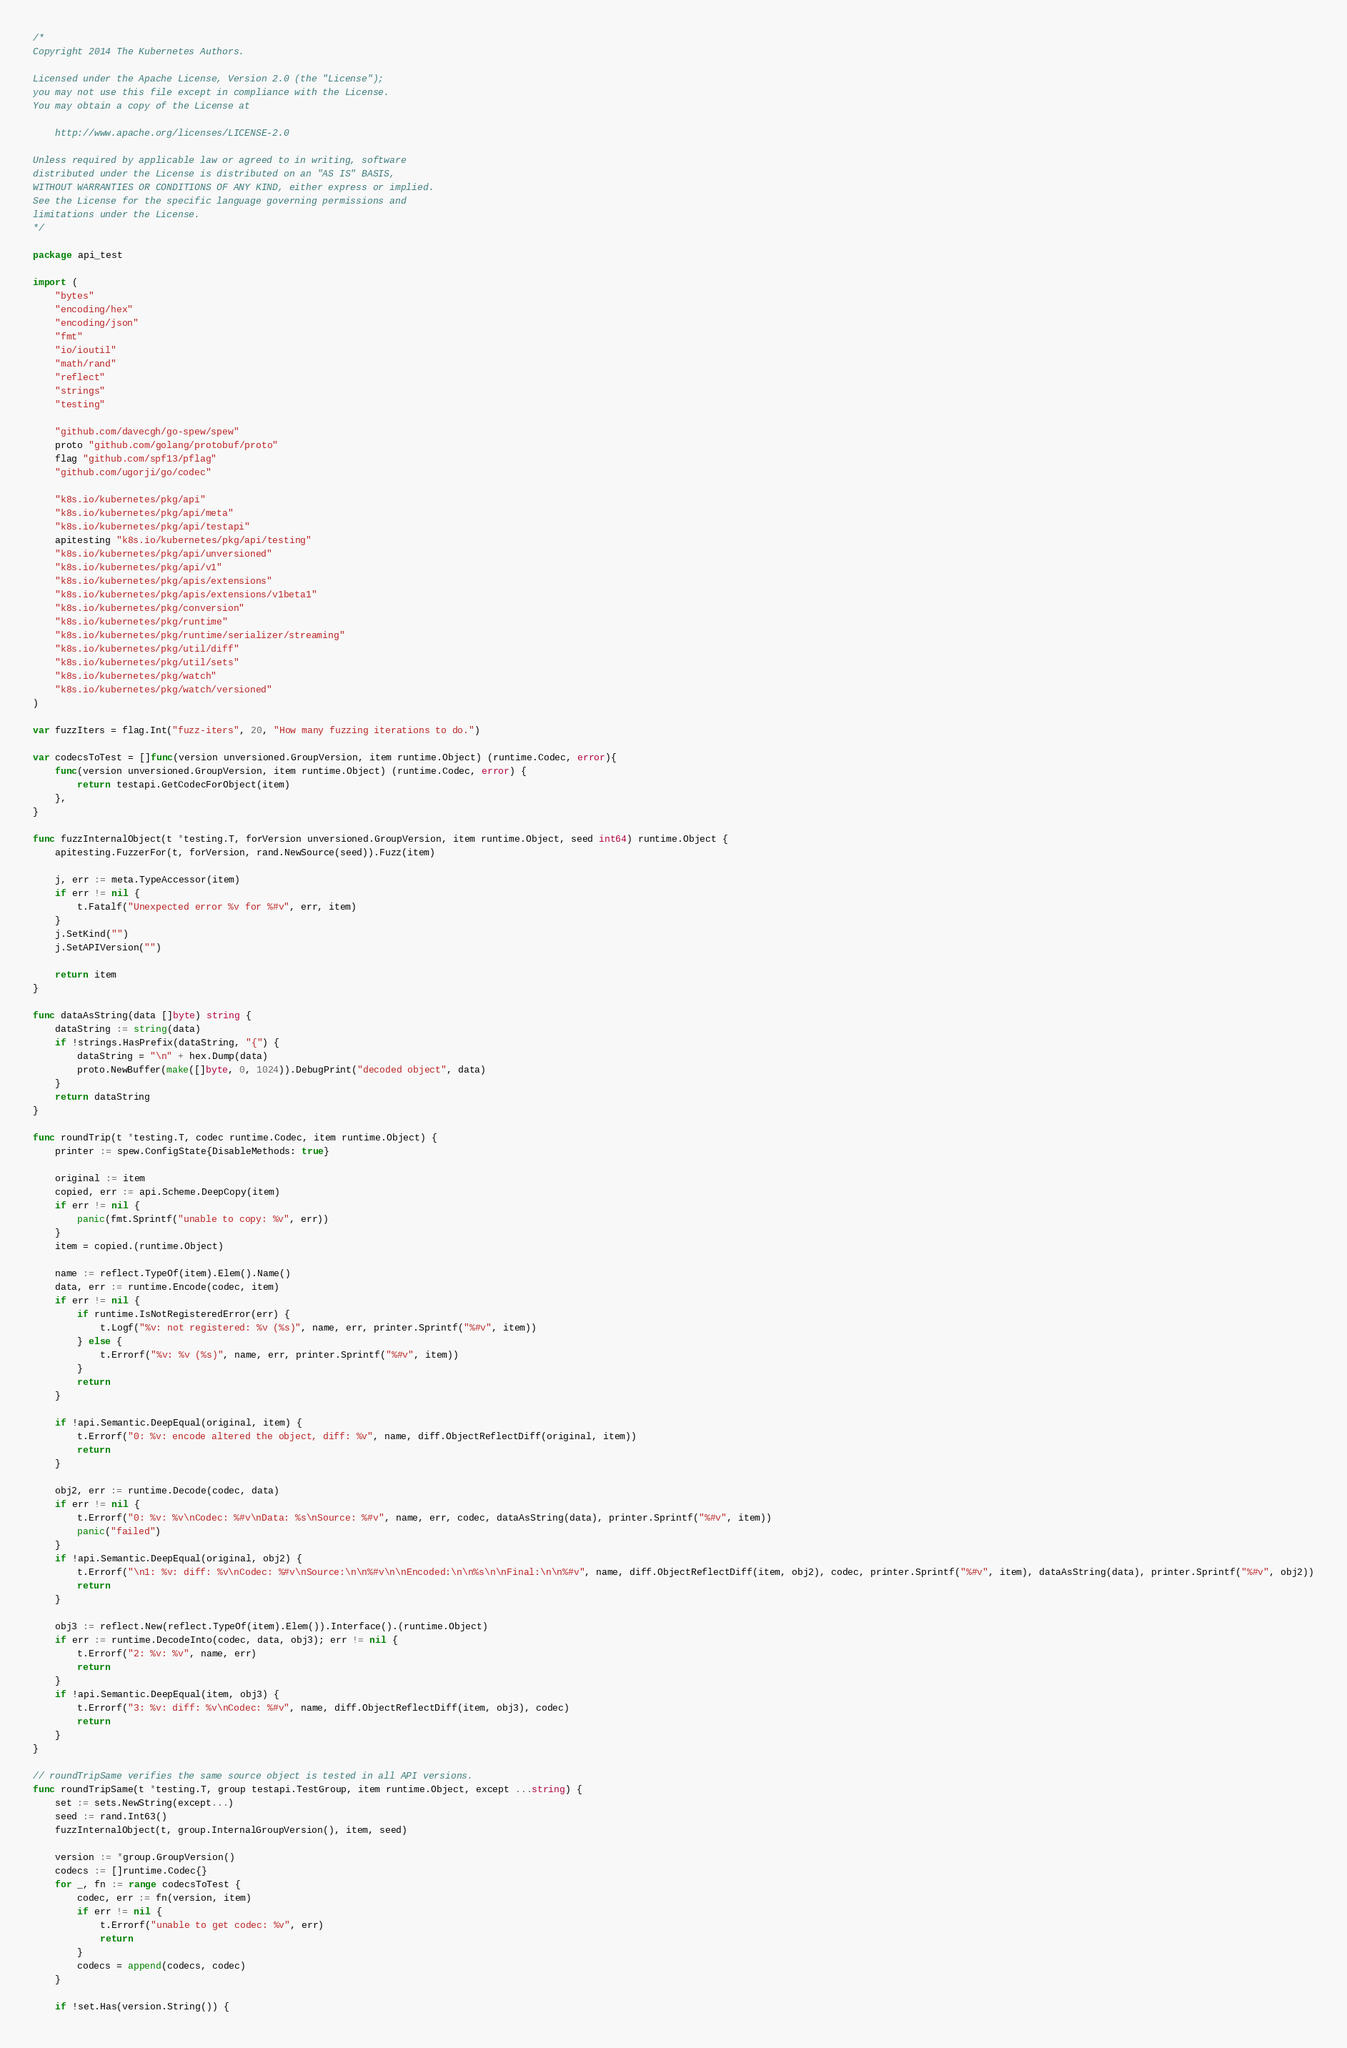<code> <loc_0><loc_0><loc_500><loc_500><_Go_>/*
Copyright 2014 The Kubernetes Authors.

Licensed under the Apache License, Version 2.0 (the "License");
you may not use this file except in compliance with the License.
You may obtain a copy of the License at

    http://www.apache.org/licenses/LICENSE-2.0

Unless required by applicable law or agreed to in writing, software
distributed under the License is distributed on an "AS IS" BASIS,
WITHOUT WARRANTIES OR CONDITIONS OF ANY KIND, either express or implied.
See the License for the specific language governing permissions and
limitations under the License.
*/

package api_test

import (
	"bytes"
	"encoding/hex"
	"encoding/json"
	"fmt"
	"io/ioutil"
	"math/rand"
	"reflect"
	"strings"
	"testing"

	"github.com/davecgh/go-spew/spew"
	proto "github.com/golang/protobuf/proto"
	flag "github.com/spf13/pflag"
	"github.com/ugorji/go/codec"

	"k8s.io/kubernetes/pkg/api"
	"k8s.io/kubernetes/pkg/api/meta"
	"k8s.io/kubernetes/pkg/api/testapi"
	apitesting "k8s.io/kubernetes/pkg/api/testing"
	"k8s.io/kubernetes/pkg/api/unversioned"
	"k8s.io/kubernetes/pkg/api/v1"
	"k8s.io/kubernetes/pkg/apis/extensions"
	"k8s.io/kubernetes/pkg/apis/extensions/v1beta1"
	"k8s.io/kubernetes/pkg/conversion"
	"k8s.io/kubernetes/pkg/runtime"
	"k8s.io/kubernetes/pkg/runtime/serializer/streaming"
	"k8s.io/kubernetes/pkg/util/diff"
	"k8s.io/kubernetes/pkg/util/sets"
	"k8s.io/kubernetes/pkg/watch"
	"k8s.io/kubernetes/pkg/watch/versioned"
)

var fuzzIters = flag.Int("fuzz-iters", 20, "How many fuzzing iterations to do.")

var codecsToTest = []func(version unversioned.GroupVersion, item runtime.Object) (runtime.Codec, error){
	func(version unversioned.GroupVersion, item runtime.Object) (runtime.Codec, error) {
		return testapi.GetCodecForObject(item)
	},
}

func fuzzInternalObject(t *testing.T, forVersion unversioned.GroupVersion, item runtime.Object, seed int64) runtime.Object {
	apitesting.FuzzerFor(t, forVersion, rand.NewSource(seed)).Fuzz(item)

	j, err := meta.TypeAccessor(item)
	if err != nil {
		t.Fatalf("Unexpected error %v for %#v", err, item)
	}
	j.SetKind("")
	j.SetAPIVersion("")

	return item
}

func dataAsString(data []byte) string {
	dataString := string(data)
	if !strings.HasPrefix(dataString, "{") {
		dataString = "\n" + hex.Dump(data)
		proto.NewBuffer(make([]byte, 0, 1024)).DebugPrint("decoded object", data)
	}
	return dataString
}

func roundTrip(t *testing.T, codec runtime.Codec, item runtime.Object) {
	printer := spew.ConfigState{DisableMethods: true}

	original := item
	copied, err := api.Scheme.DeepCopy(item)
	if err != nil {
		panic(fmt.Sprintf("unable to copy: %v", err))
	}
	item = copied.(runtime.Object)

	name := reflect.TypeOf(item).Elem().Name()
	data, err := runtime.Encode(codec, item)
	if err != nil {
		if runtime.IsNotRegisteredError(err) {
			t.Logf("%v: not registered: %v (%s)", name, err, printer.Sprintf("%#v", item))
		} else {
			t.Errorf("%v: %v (%s)", name, err, printer.Sprintf("%#v", item))
		}
		return
	}

	if !api.Semantic.DeepEqual(original, item) {
		t.Errorf("0: %v: encode altered the object, diff: %v", name, diff.ObjectReflectDiff(original, item))
		return
	}

	obj2, err := runtime.Decode(codec, data)
	if err != nil {
		t.Errorf("0: %v: %v\nCodec: %#v\nData: %s\nSource: %#v", name, err, codec, dataAsString(data), printer.Sprintf("%#v", item))
		panic("failed")
	}
	if !api.Semantic.DeepEqual(original, obj2) {
		t.Errorf("\n1: %v: diff: %v\nCodec: %#v\nSource:\n\n%#v\n\nEncoded:\n\n%s\n\nFinal:\n\n%#v", name, diff.ObjectReflectDiff(item, obj2), codec, printer.Sprintf("%#v", item), dataAsString(data), printer.Sprintf("%#v", obj2))
		return
	}

	obj3 := reflect.New(reflect.TypeOf(item).Elem()).Interface().(runtime.Object)
	if err := runtime.DecodeInto(codec, data, obj3); err != nil {
		t.Errorf("2: %v: %v", name, err)
		return
	}
	if !api.Semantic.DeepEqual(item, obj3) {
		t.Errorf("3: %v: diff: %v\nCodec: %#v", name, diff.ObjectReflectDiff(item, obj3), codec)
		return
	}
}

// roundTripSame verifies the same source object is tested in all API versions.
func roundTripSame(t *testing.T, group testapi.TestGroup, item runtime.Object, except ...string) {
	set := sets.NewString(except...)
	seed := rand.Int63()
	fuzzInternalObject(t, group.InternalGroupVersion(), item, seed)

	version := *group.GroupVersion()
	codecs := []runtime.Codec{}
	for _, fn := range codecsToTest {
		codec, err := fn(version, item)
		if err != nil {
			t.Errorf("unable to get codec: %v", err)
			return
		}
		codecs = append(codecs, codec)
	}

	if !set.Has(version.String()) {</code> 